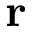<formula> <loc_0><loc_0><loc_500><loc_500>{ r }</formula> 